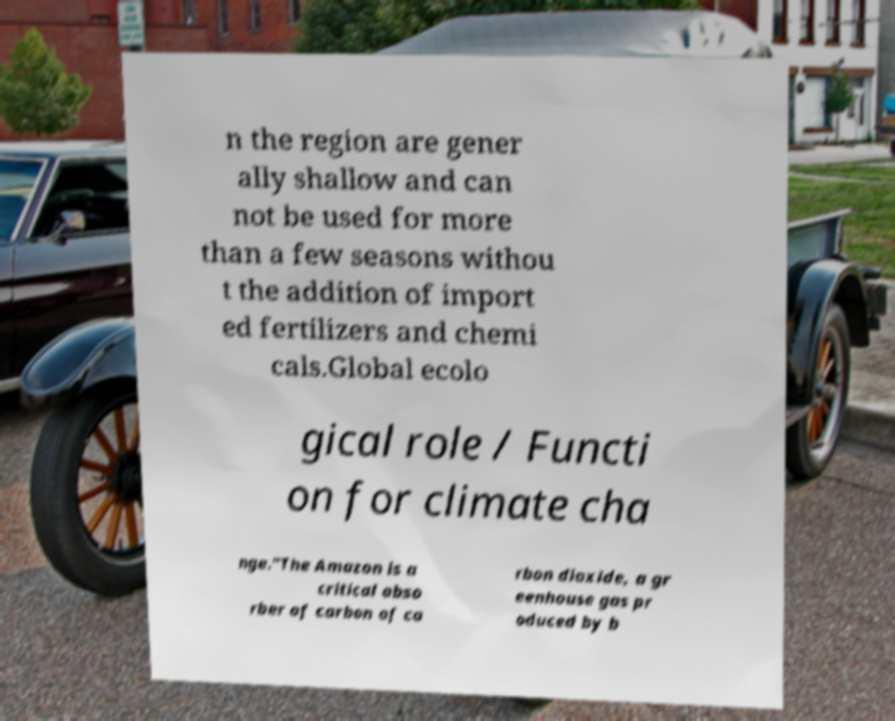For documentation purposes, I need the text within this image transcribed. Could you provide that? n the region are gener ally shallow and can not be used for more than a few seasons withou t the addition of import ed fertilizers and chemi cals.Global ecolo gical role / Functi on for climate cha nge."The Amazon is a critical abso rber of carbon of ca rbon dioxide, a gr eenhouse gas pr oduced by b 